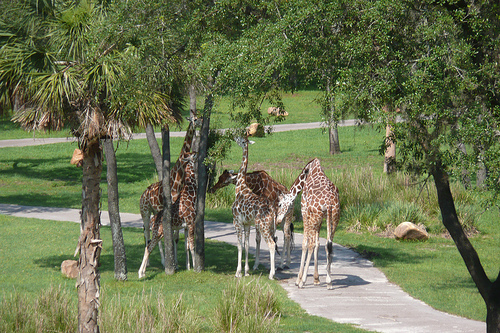How many giraffes? 4 